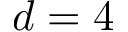<formula> <loc_0><loc_0><loc_500><loc_500>d = 4</formula> 